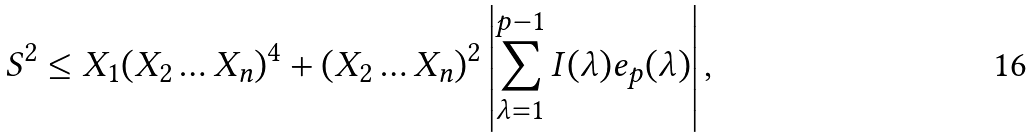Convert formula to latex. <formula><loc_0><loc_0><loc_500><loc_500>S ^ { 2 } \leq X _ { 1 } ( X _ { 2 } \dots X _ { n } ) ^ { 4 } + ( X _ { 2 } \dots X _ { n } ) ^ { 2 } \left | \sum _ { \lambda = 1 } ^ { p - 1 } I ( \lambda ) e _ { p } ( \lambda ) \right | ,</formula> 